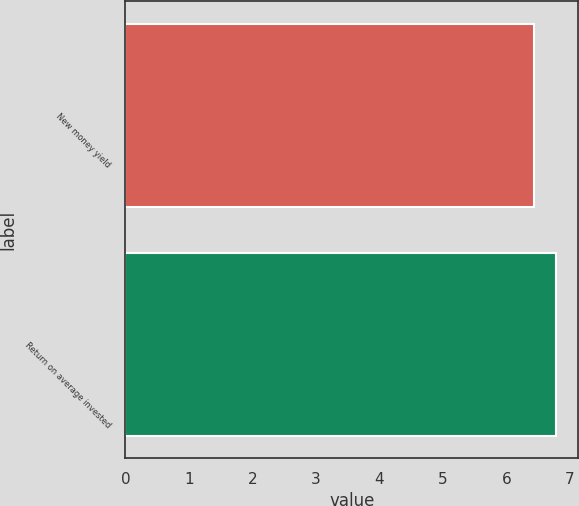Convert chart. <chart><loc_0><loc_0><loc_500><loc_500><bar_chart><fcel>New money yield<fcel>Return on average invested<nl><fcel>6.44<fcel>6.79<nl></chart> 